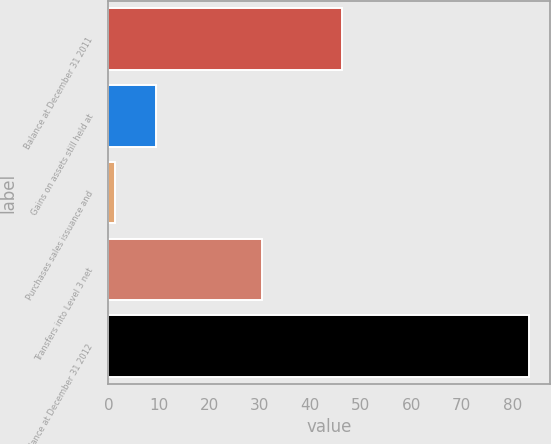<chart> <loc_0><loc_0><loc_500><loc_500><bar_chart><fcel>Balance at December 31 2011<fcel>Gains on assets still held at<fcel>Purchases sales issuance and<fcel>Transfers into Level 3 net<fcel>Balance at December 31 2012<nl><fcel>46.3<fcel>9.51<fcel>1.3<fcel>30.5<fcel>83.4<nl></chart> 